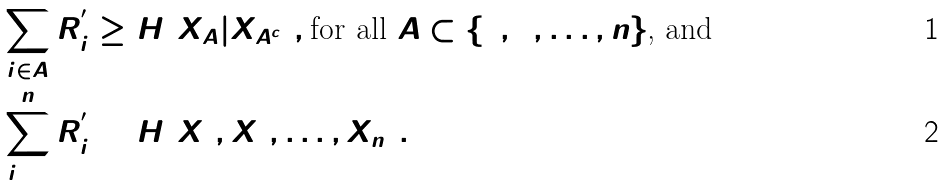<formula> <loc_0><loc_0><loc_500><loc_500>\sum _ { i \in A } R _ { i } ^ { ^ { \prime } } & \geq H ( X _ { A } | X _ { A ^ { c } } ) , \text {for all $A \subset \{1, 2, \dots , n\}$, and} \\ \sum _ { i = 1 } ^ { n } R _ { i } ^ { ^ { \prime } } & = H ( X _ { 1 } , X _ { 2 } , \dots , X _ { n } ) .</formula> 